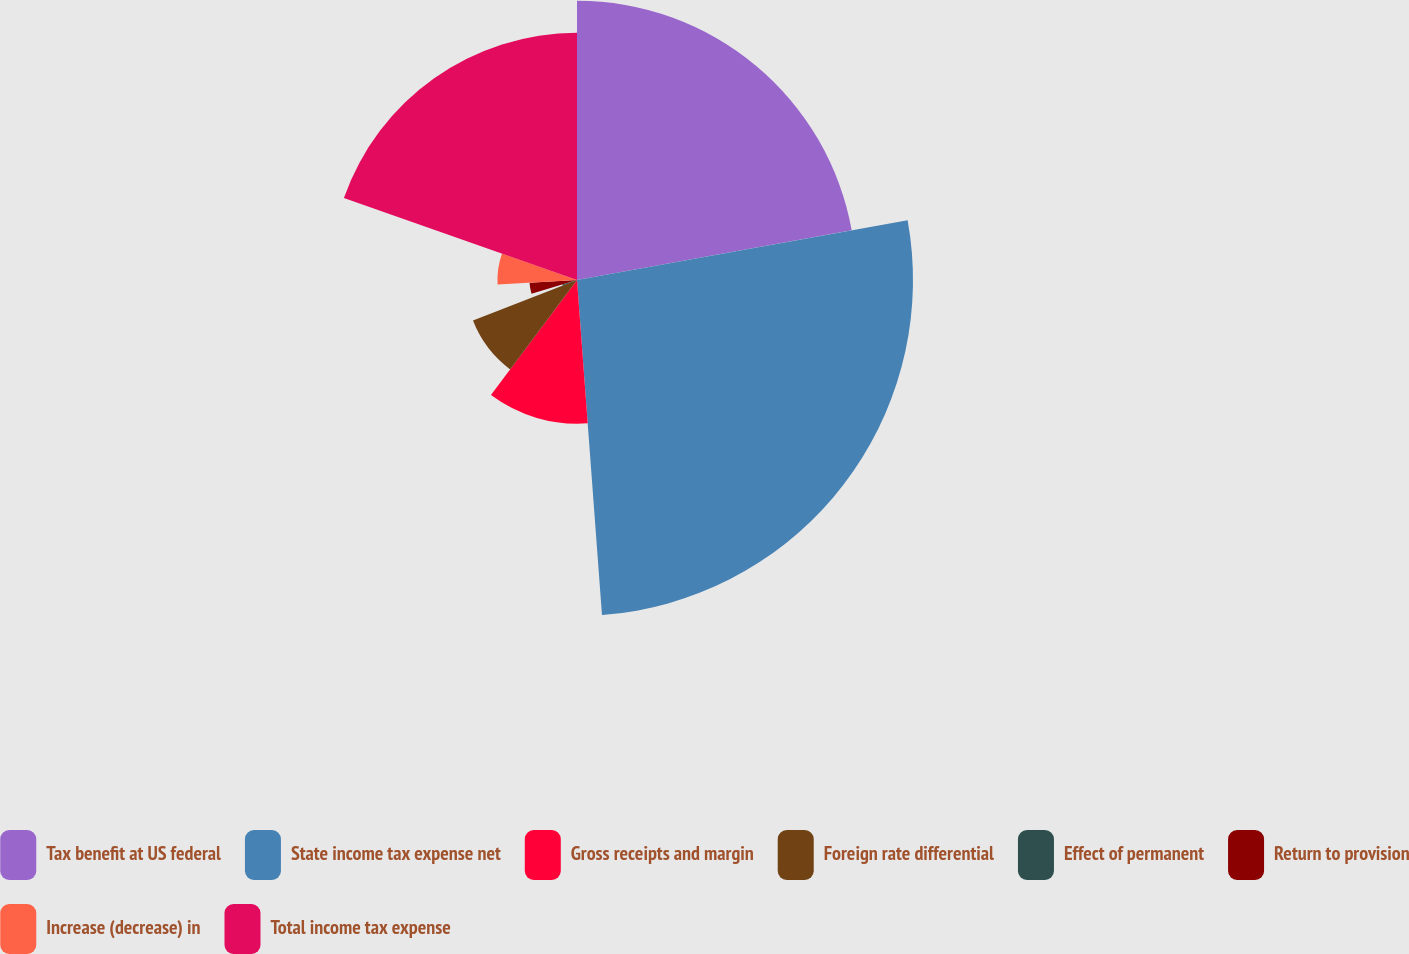<chart> <loc_0><loc_0><loc_500><loc_500><pie_chart><fcel>Tax benefit at US federal<fcel>State income tax expense net<fcel>Gross receipts and margin<fcel>Foreign rate differential<fcel>Effect of permanent<fcel>Return to provision<fcel>Increase (decrease) in<fcel>Total income tax expense<nl><fcel>22.15%<fcel>26.66%<fcel>11.4%<fcel>8.86%<fcel>1.23%<fcel>3.77%<fcel>6.31%<fcel>19.61%<nl></chart> 